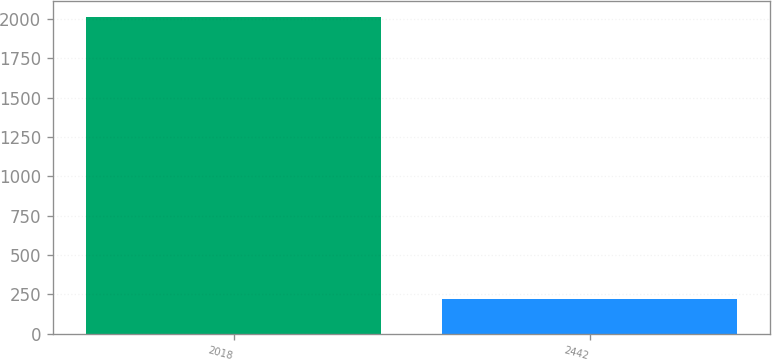Convert chart to OTSL. <chart><loc_0><loc_0><loc_500><loc_500><bar_chart><fcel>2018<fcel>2442<nl><fcel>2016<fcel>219.1<nl></chart> 